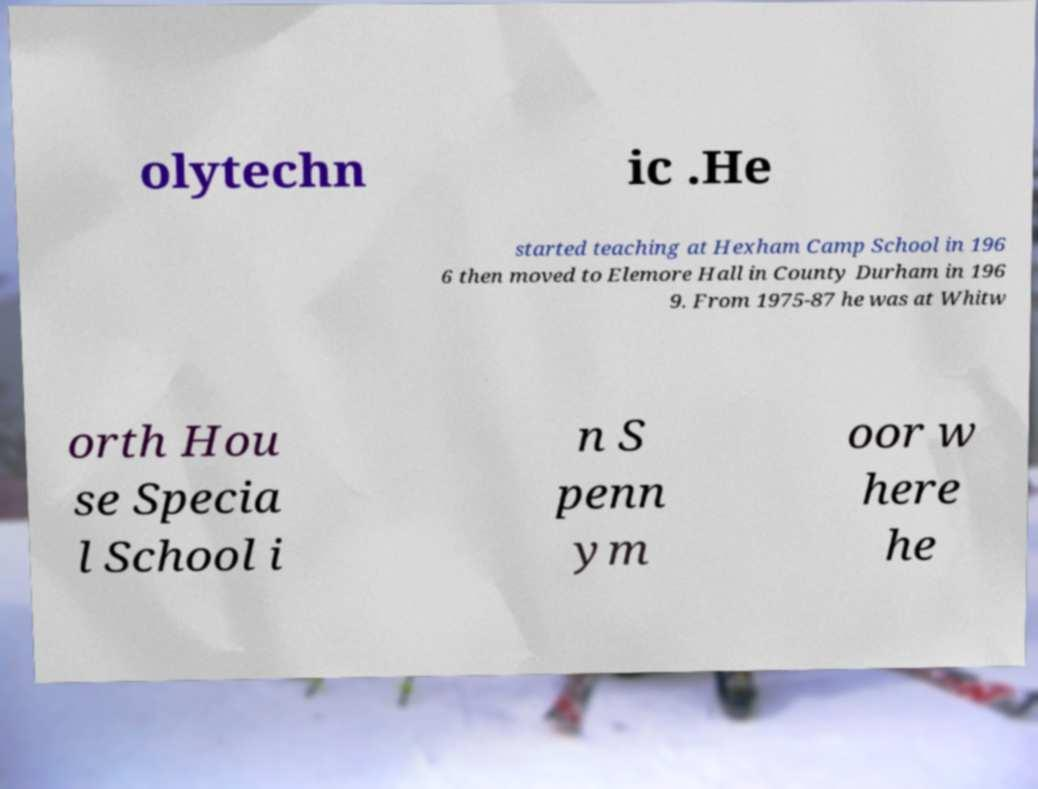Can you read and provide the text displayed in the image?This photo seems to have some interesting text. Can you extract and type it out for me? olytechn ic .He started teaching at Hexham Camp School in 196 6 then moved to Elemore Hall in County Durham in 196 9. From 1975-87 he was at Whitw orth Hou se Specia l School i n S penn ym oor w here he 